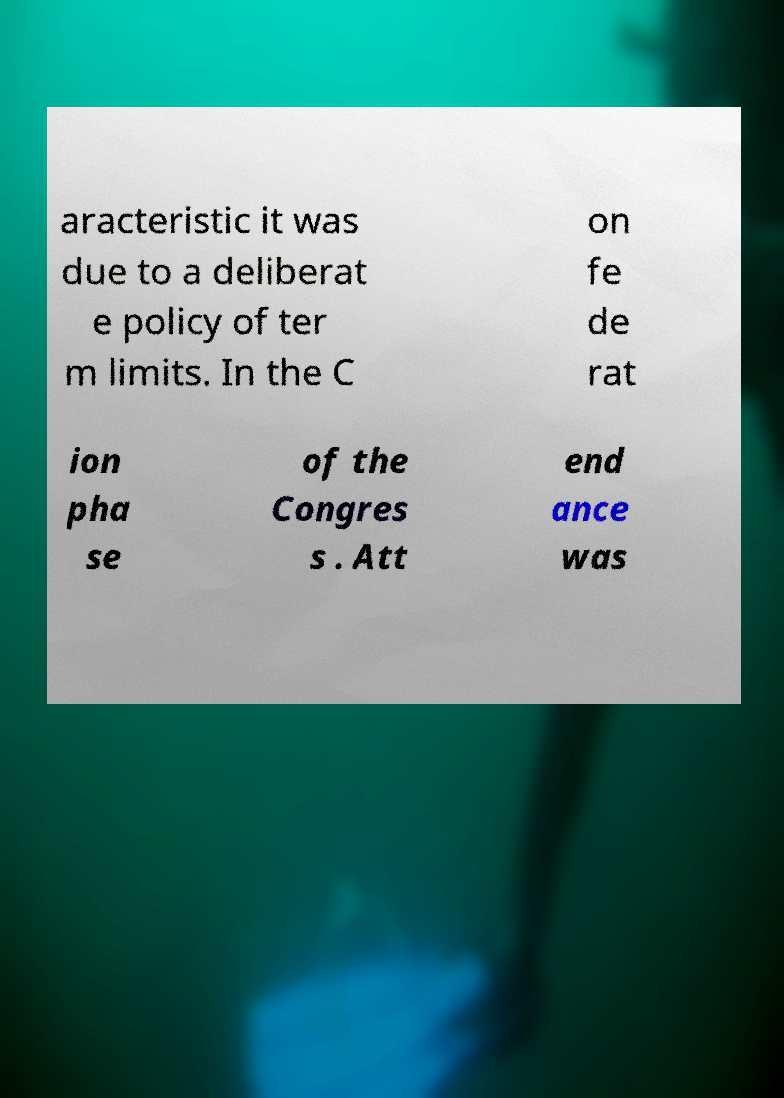Can you accurately transcribe the text from the provided image for me? aracteristic it was due to a deliberat e policy of ter m limits. In the C on fe de rat ion pha se of the Congres s . Att end ance was 